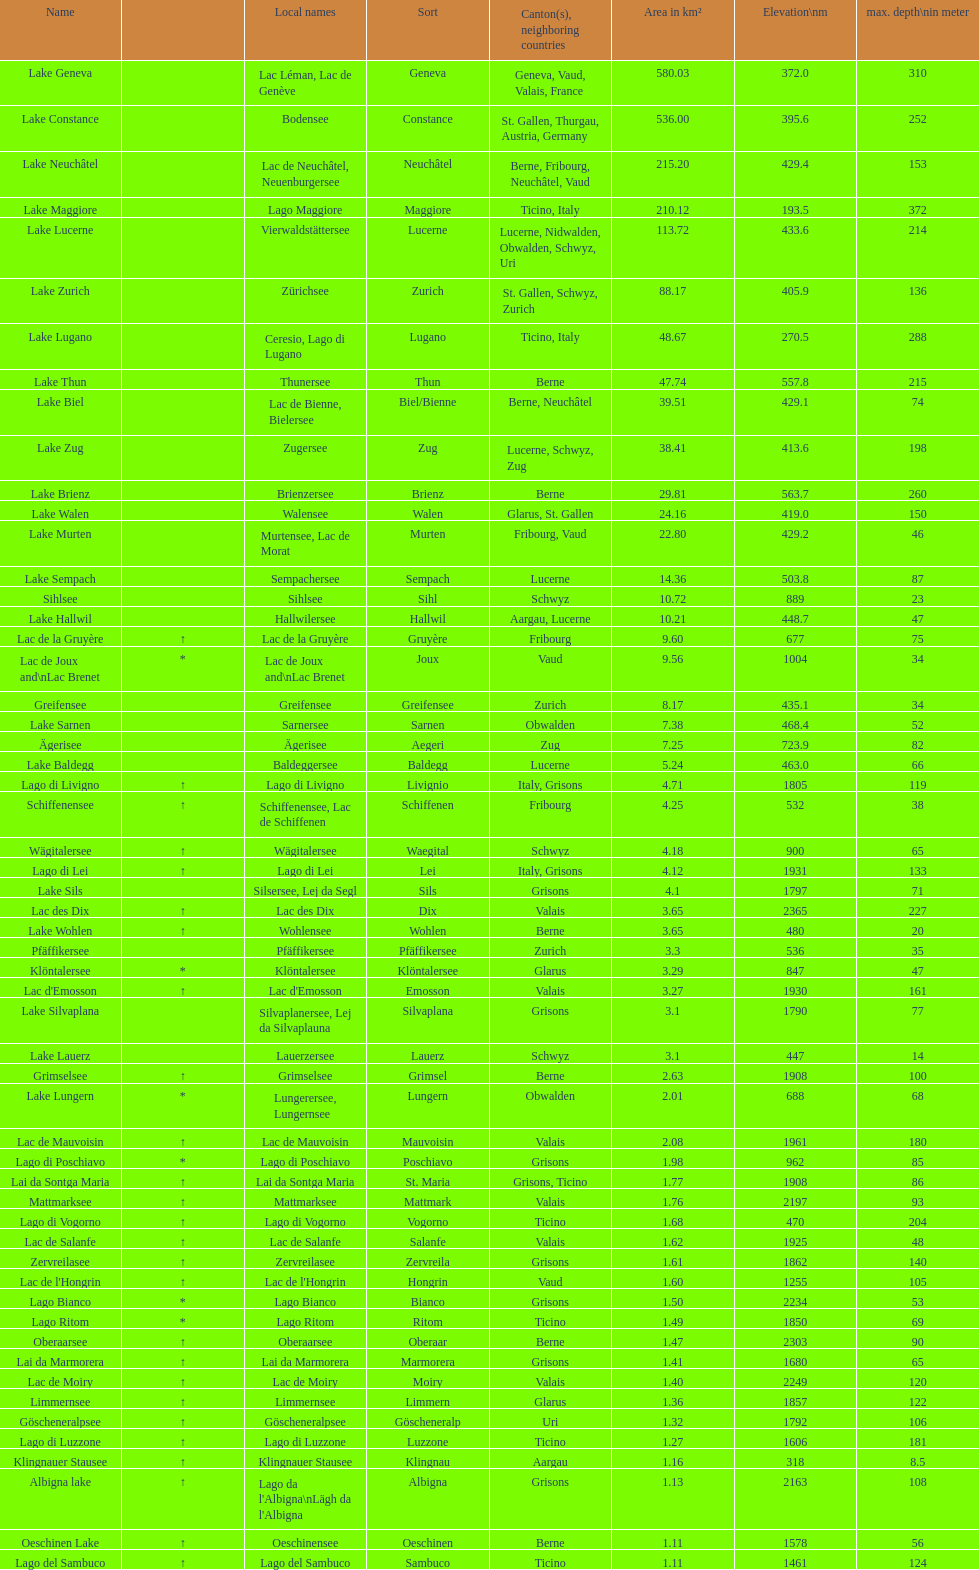Which lake occupies a smaller area in km²? albigna lake or oeschinen lake? Oeschinen Lake. 